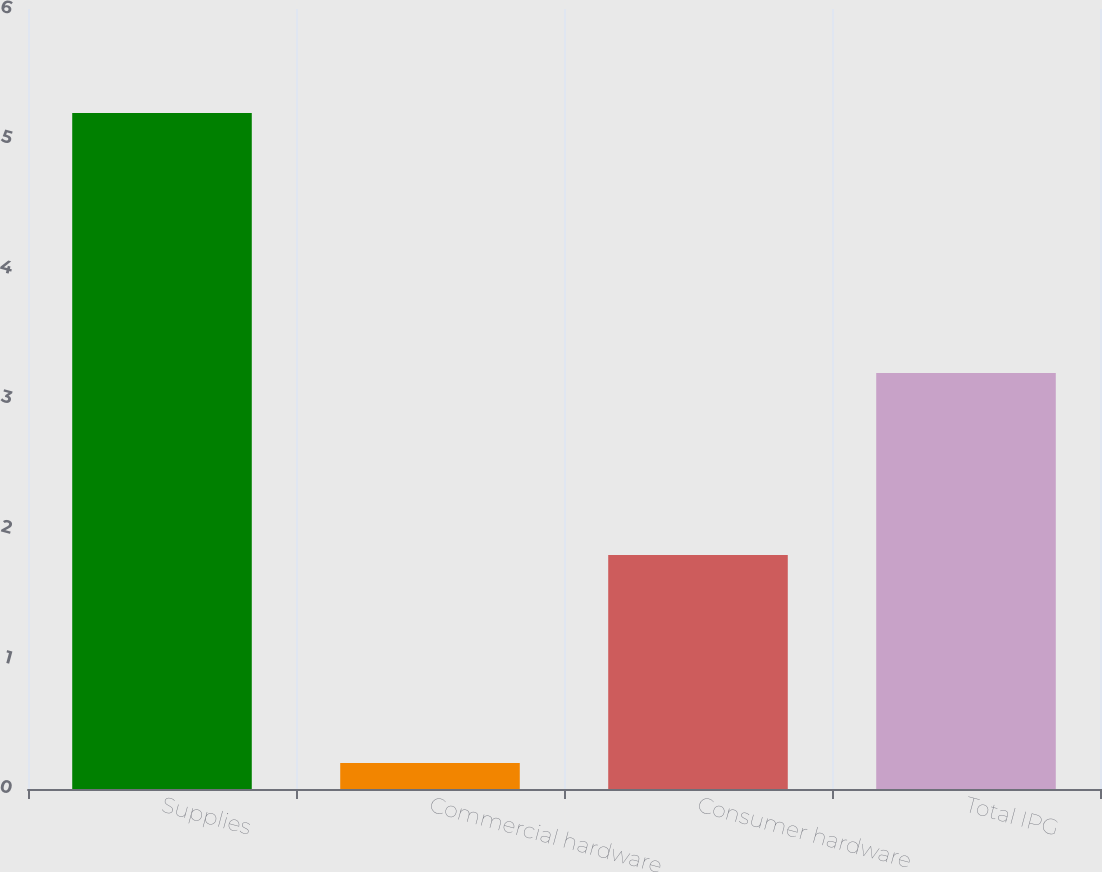<chart> <loc_0><loc_0><loc_500><loc_500><bar_chart><fcel>Supplies<fcel>Commercial hardware<fcel>Consumer hardware<fcel>Total IPG<nl><fcel>5.2<fcel>0.2<fcel>1.8<fcel>3.2<nl></chart> 